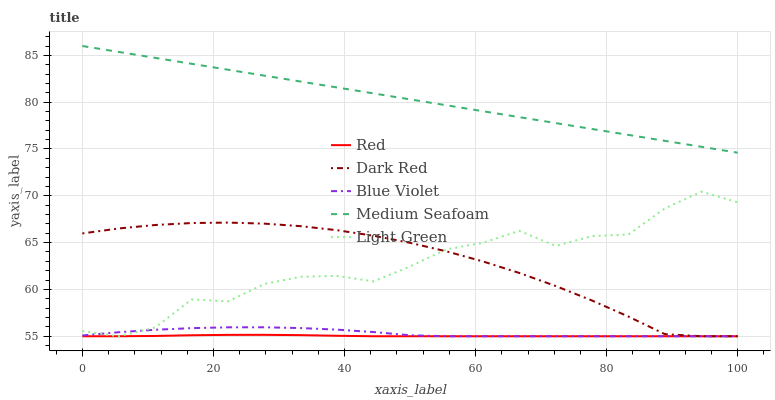Does Light Green have the minimum area under the curve?
Answer yes or no. No. Does Light Green have the maximum area under the curve?
Answer yes or no. No. Is Blue Violet the smoothest?
Answer yes or no. No. Is Blue Violet the roughest?
Answer yes or no. No. Does Medium Seafoam have the lowest value?
Answer yes or no. No. Does Light Green have the highest value?
Answer yes or no. No. Is Dark Red less than Medium Seafoam?
Answer yes or no. Yes. Is Medium Seafoam greater than Dark Red?
Answer yes or no. Yes. Does Dark Red intersect Medium Seafoam?
Answer yes or no. No. 